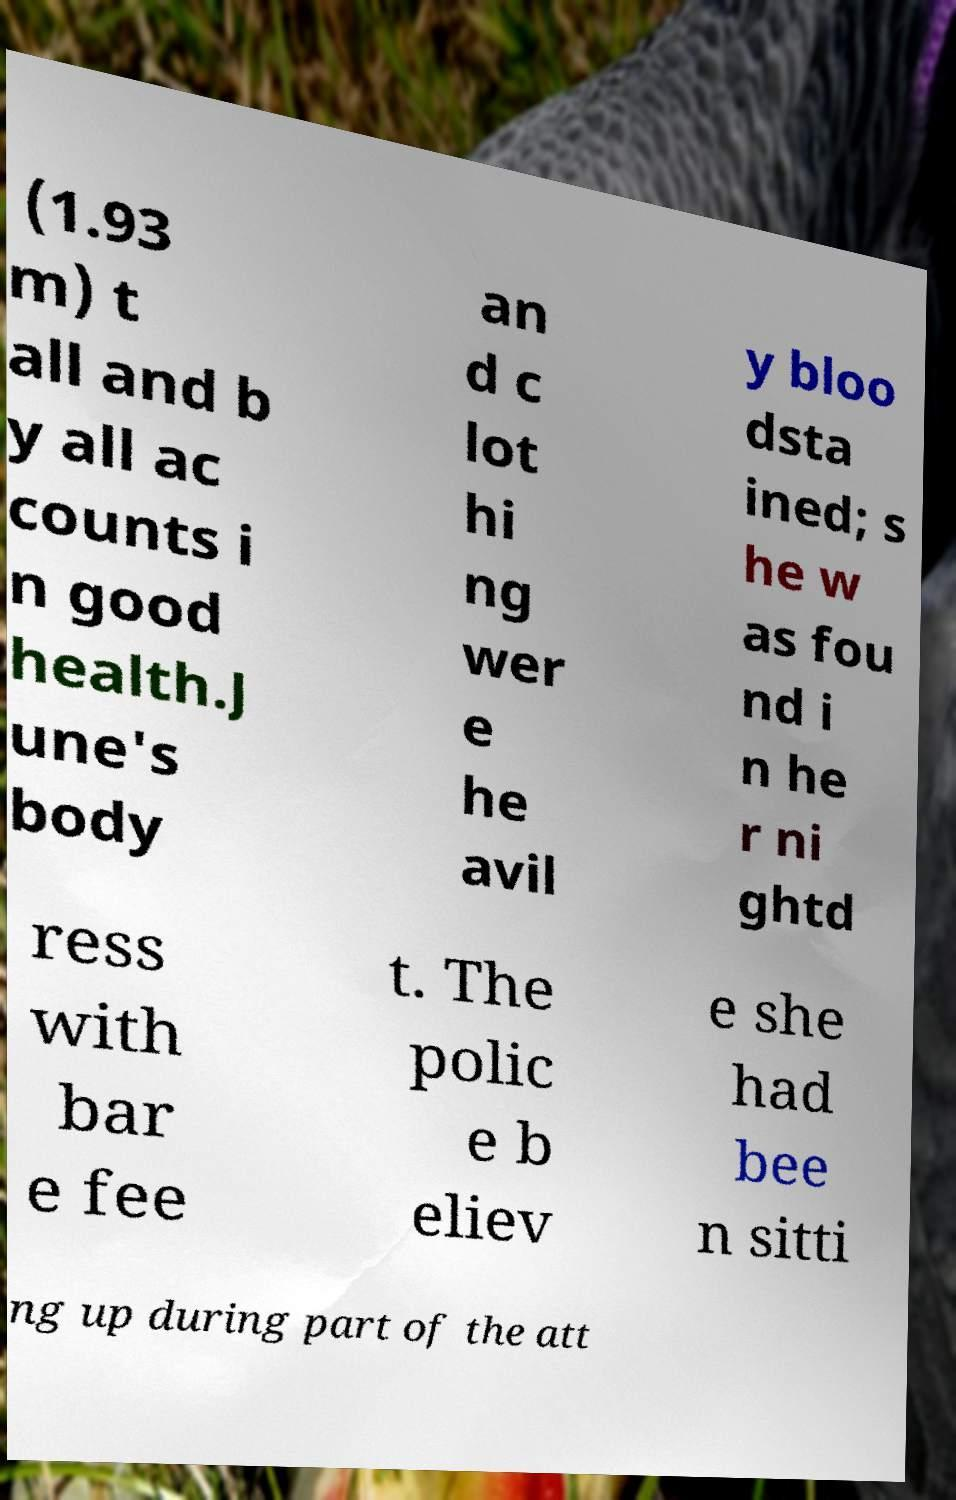Could you assist in decoding the text presented in this image and type it out clearly? (1.93 m) t all and b y all ac counts i n good health.J une's body an d c lot hi ng wer e he avil y bloo dsta ined; s he w as fou nd i n he r ni ghtd ress with bar e fee t. The polic e b eliev e she had bee n sitti ng up during part of the att 